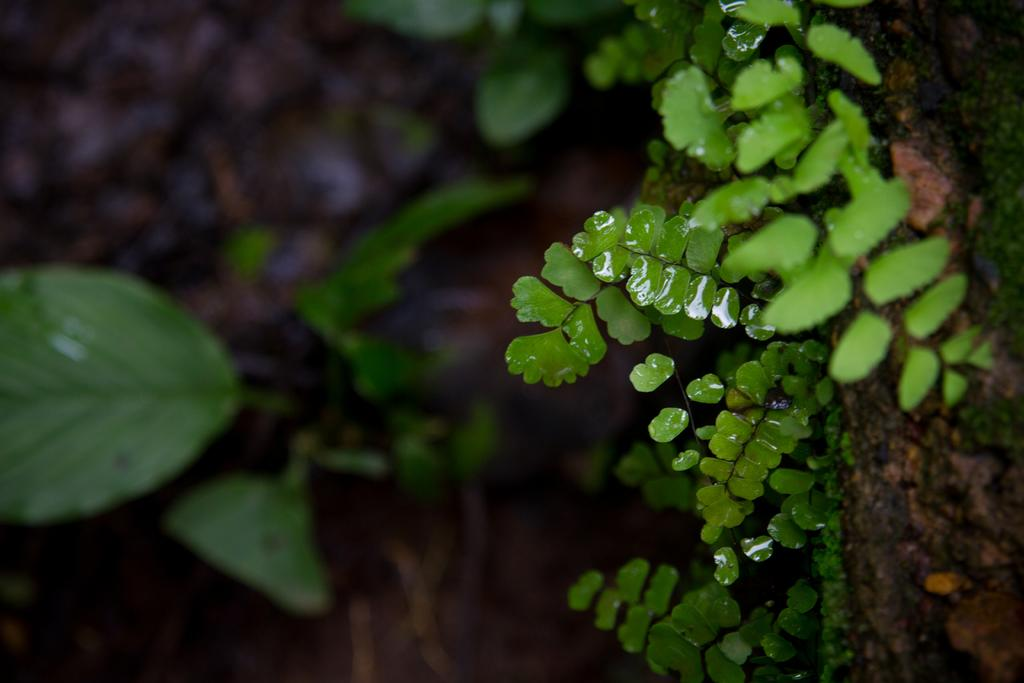What type of living organisms can be seen in the image? Plants can be seen in the image. Can you describe the tree trunk in the image? There is a tree trunk on the right side in the front of the image. What type of cup is being used to hold the paper in the image? There is no cup or paper present in the image; it only features plants and a tree trunk. 